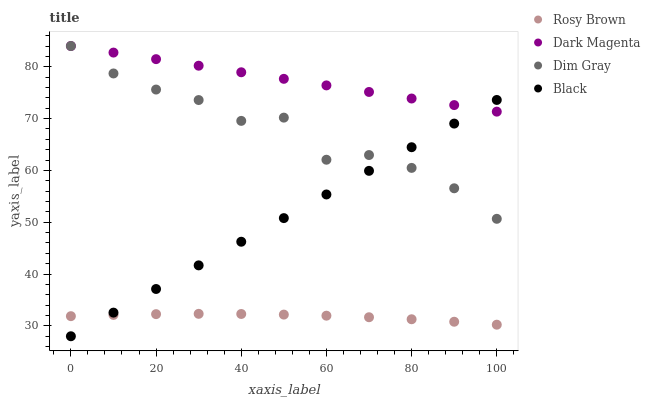Does Rosy Brown have the minimum area under the curve?
Answer yes or no. Yes. Does Dark Magenta have the maximum area under the curve?
Answer yes or no. Yes. Does Black have the minimum area under the curve?
Answer yes or no. No. Does Black have the maximum area under the curve?
Answer yes or no. No. Is Black the smoothest?
Answer yes or no. Yes. Is Dim Gray the roughest?
Answer yes or no. Yes. Is Rosy Brown the smoothest?
Answer yes or no. No. Is Rosy Brown the roughest?
Answer yes or no. No. Does Black have the lowest value?
Answer yes or no. Yes. Does Rosy Brown have the lowest value?
Answer yes or no. No. Does Dark Magenta have the highest value?
Answer yes or no. Yes. Does Black have the highest value?
Answer yes or no. No. Is Rosy Brown less than Dark Magenta?
Answer yes or no. Yes. Is Dim Gray greater than Rosy Brown?
Answer yes or no. Yes. Does Dim Gray intersect Black?
Answer yes or no. Yes. Is Dim Gray less than Black?
Answer yes or no. No. Is Dim Gray greater than Black?
Answer yes or no. No. Does Rosy Brown intersect Dark Magenta?
Answer yes or no. No. 